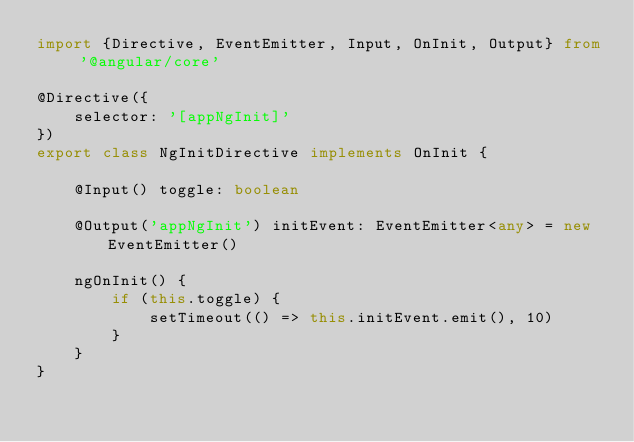<code> <loc_0><loc_0><loc_500><loc_500><_TypeScript_>import {Directive, EventEmitter, Input, OnInit, Output} from '@angular/core'

@Directive({
    selector: '[appNgInit]'
})
export class NgInitDirective implements OnInit {

    @Input() toggle: boolean

    @Output('appNgInit') initEvent: EventEmitter<any> = new EventEmitter()

    ngOnInit() {
        if (this.toggle) {
            setTimeout(() => this.initEvent.emit(), 10)
        }
    }
}
</code> 